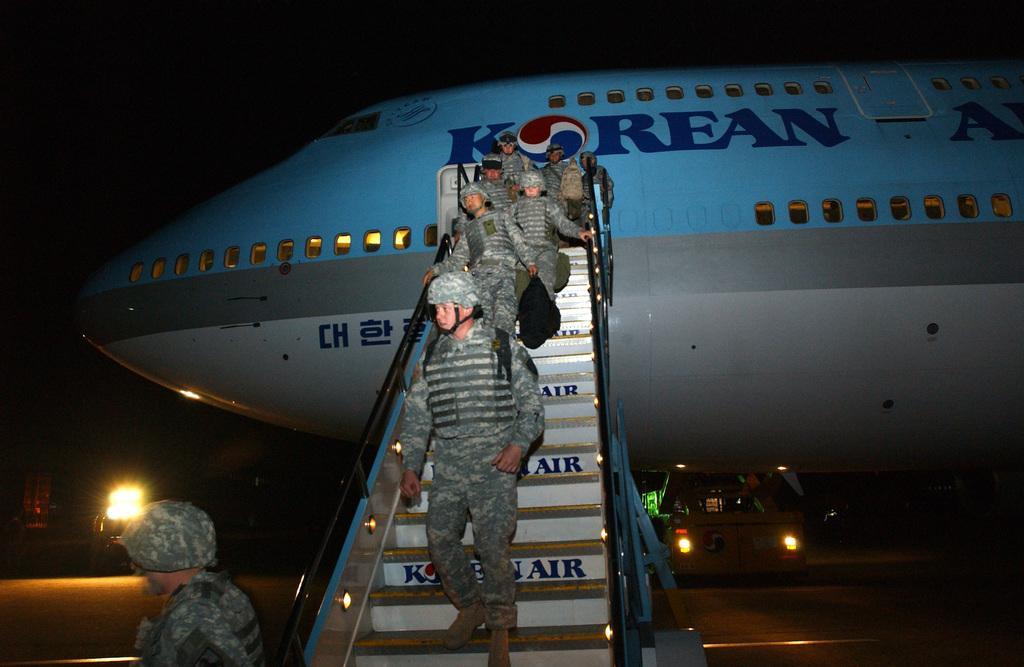Could you give a brief overview of what you see in this image? In this picture we can see an airplane, people, here we can see vehicles on the ground and in the background we can see it is dark. 